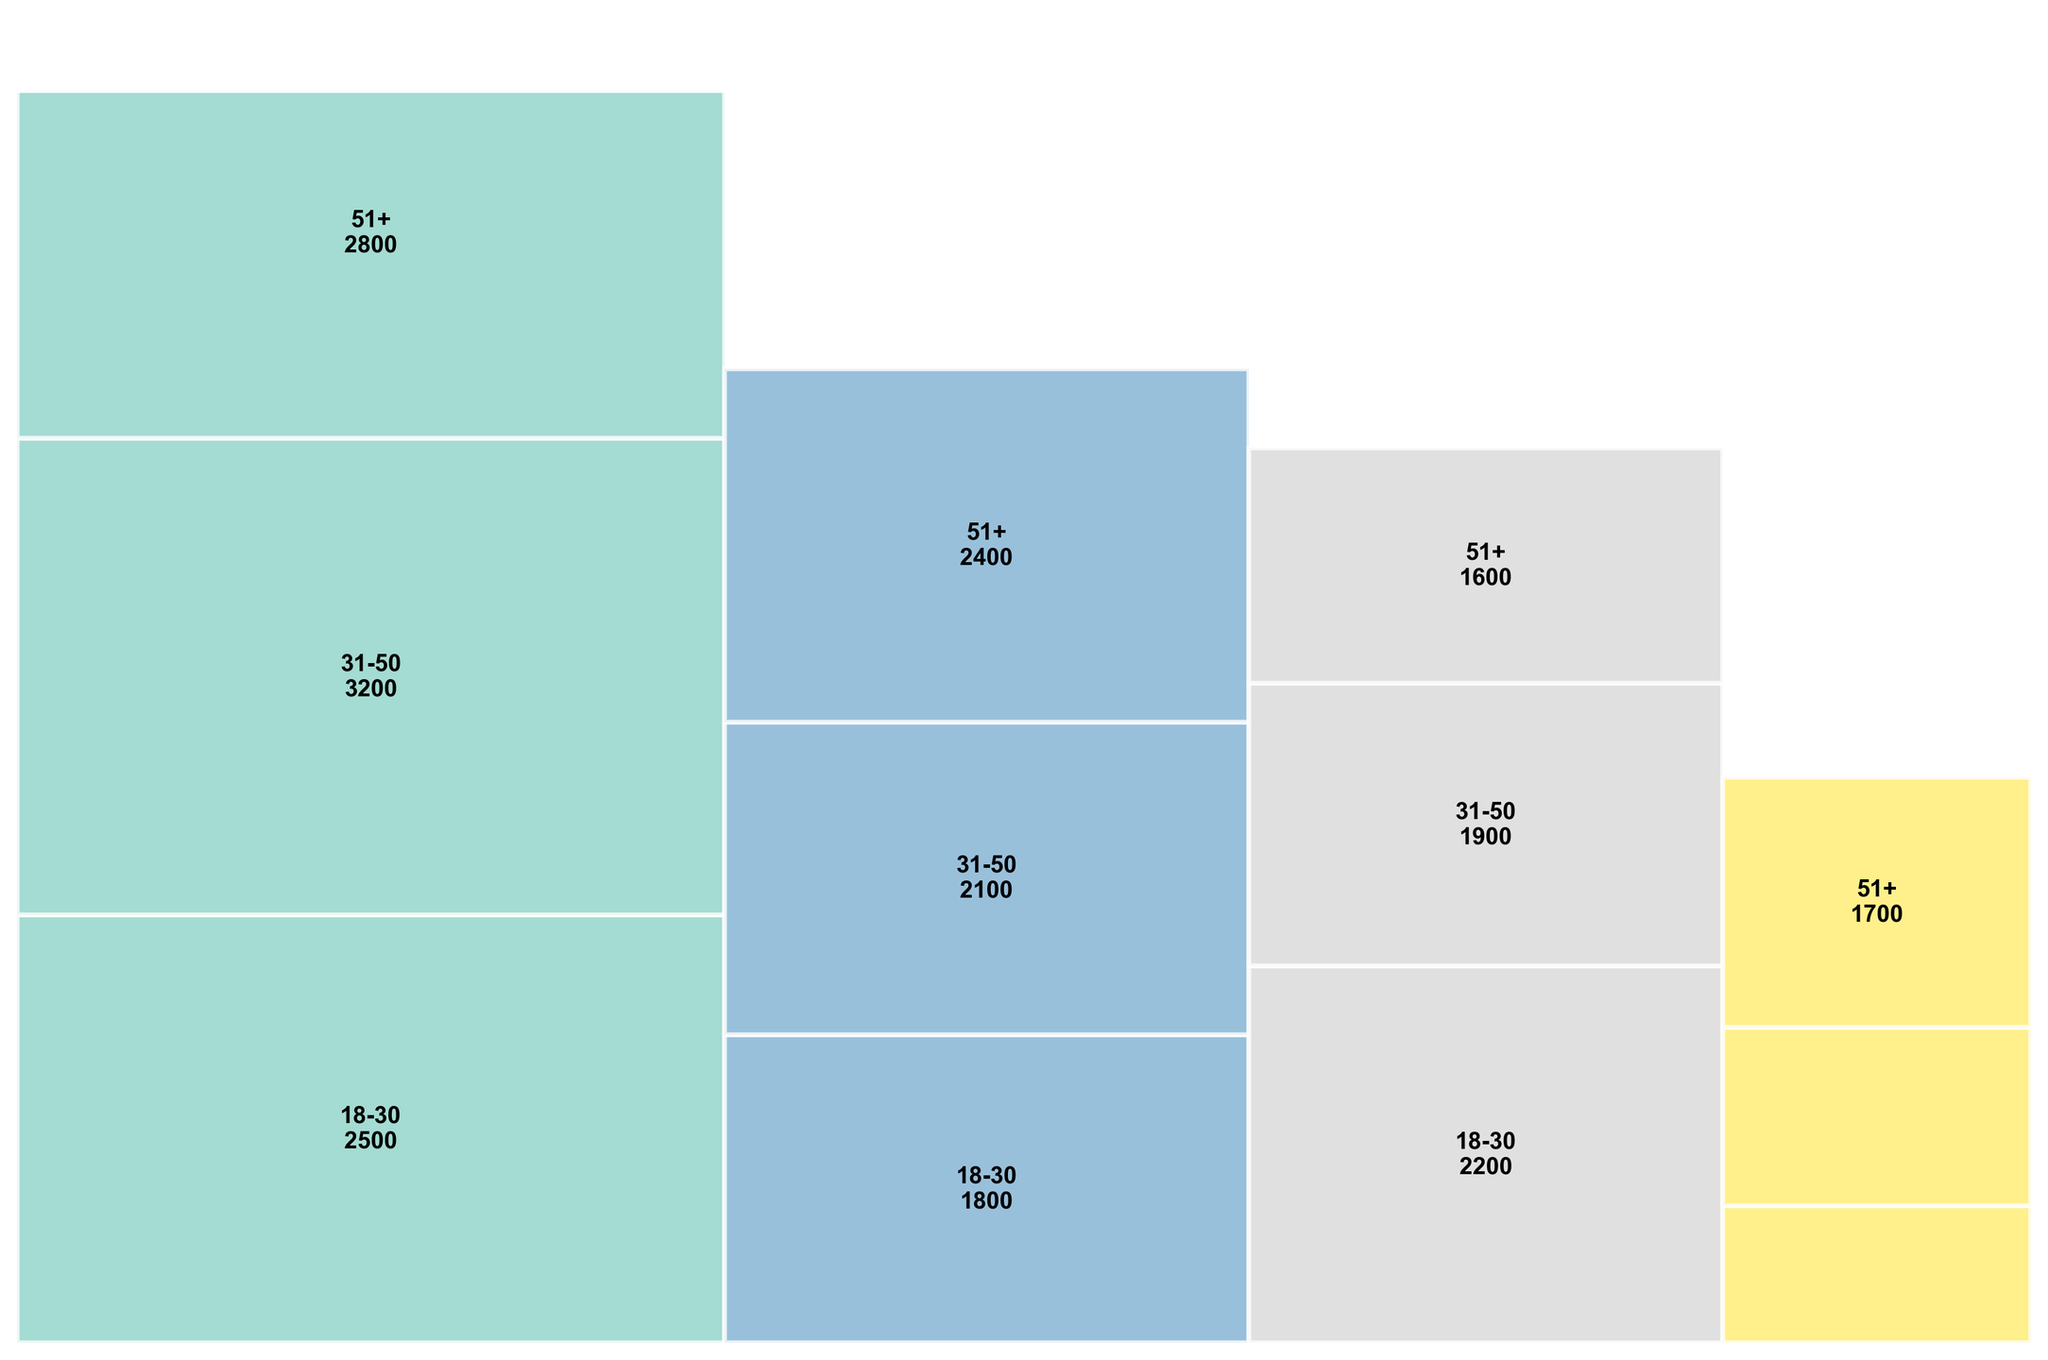What's the title of the figure? The title is written at the top of the figure. Titles generally give an overview of what the plot is about.
Answer: West End Theater Attendance by Genre and Age Group Which age group had the highest attendance for Musicals? By looking at the height of the sections within the Musical category, the 31-50 age group section is the tallest.
Answer: 31-50 What is the total attendance for the Opera genre? Each section's attendance is labeled within the Opera category. Adding these values gives 800 + 1200 + 1700, summing to 3700.
Answer: 3700 Which genre has the lowest total attendance? By comparing the widths of the genre sections, the Opera category is the narrowest, indicating the lowest total attendance.
Answer: Opera How does the attendance of the 18-30 age group for Comedies compare to that for Dramas? The figure shows the numerical values for each section. For Comedy 18-30, it's 2200, and for Drama 18-30, it's 1800. Therefore, Comedy has a higher attendance.
Answer: Comedy is higher Which genre has the most balanced attendance across age groups? By comparing the relative heights of sections in each genre, Drama shows more equal heights among the 18-30, 31-50, and 51+ sections.
Answer: Drama What can be said about the attendance of the 51+ age group across all genres? Observing the 51+ sections across genres, they tend to vary. In Musicals, the number is high (2800), similar to Drama (2400), but lower in Comedies (1600), and medium in Opera (1700).
Answer: Varied Which genre has the most significant difference in attendance between any two age groups? By comparing all genres, Musicals show the largest difference. 31-50 (3200) vs. 18-30 (2500) has a difference of 700.
Answer: Musical What percentage of total attendance is accounted for by the 31-50 age group in Dramas? The total drama attendance is 1800 + 2100 + 2400 = 6300, and 31-50 age group in Dramas is 2100. So, (2100 / 6300 ) * 100 ≈ 33.33%.
Answer: 33.33% Which age group attended Operas the least? By comparing the labels under the Opera genre, 18-30 has lowest attendance with 800.
Answer: 18-30 